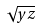<formula> <loc_0><loc_0><loc_500><loc_500>\sqrt { y z }</formula> 